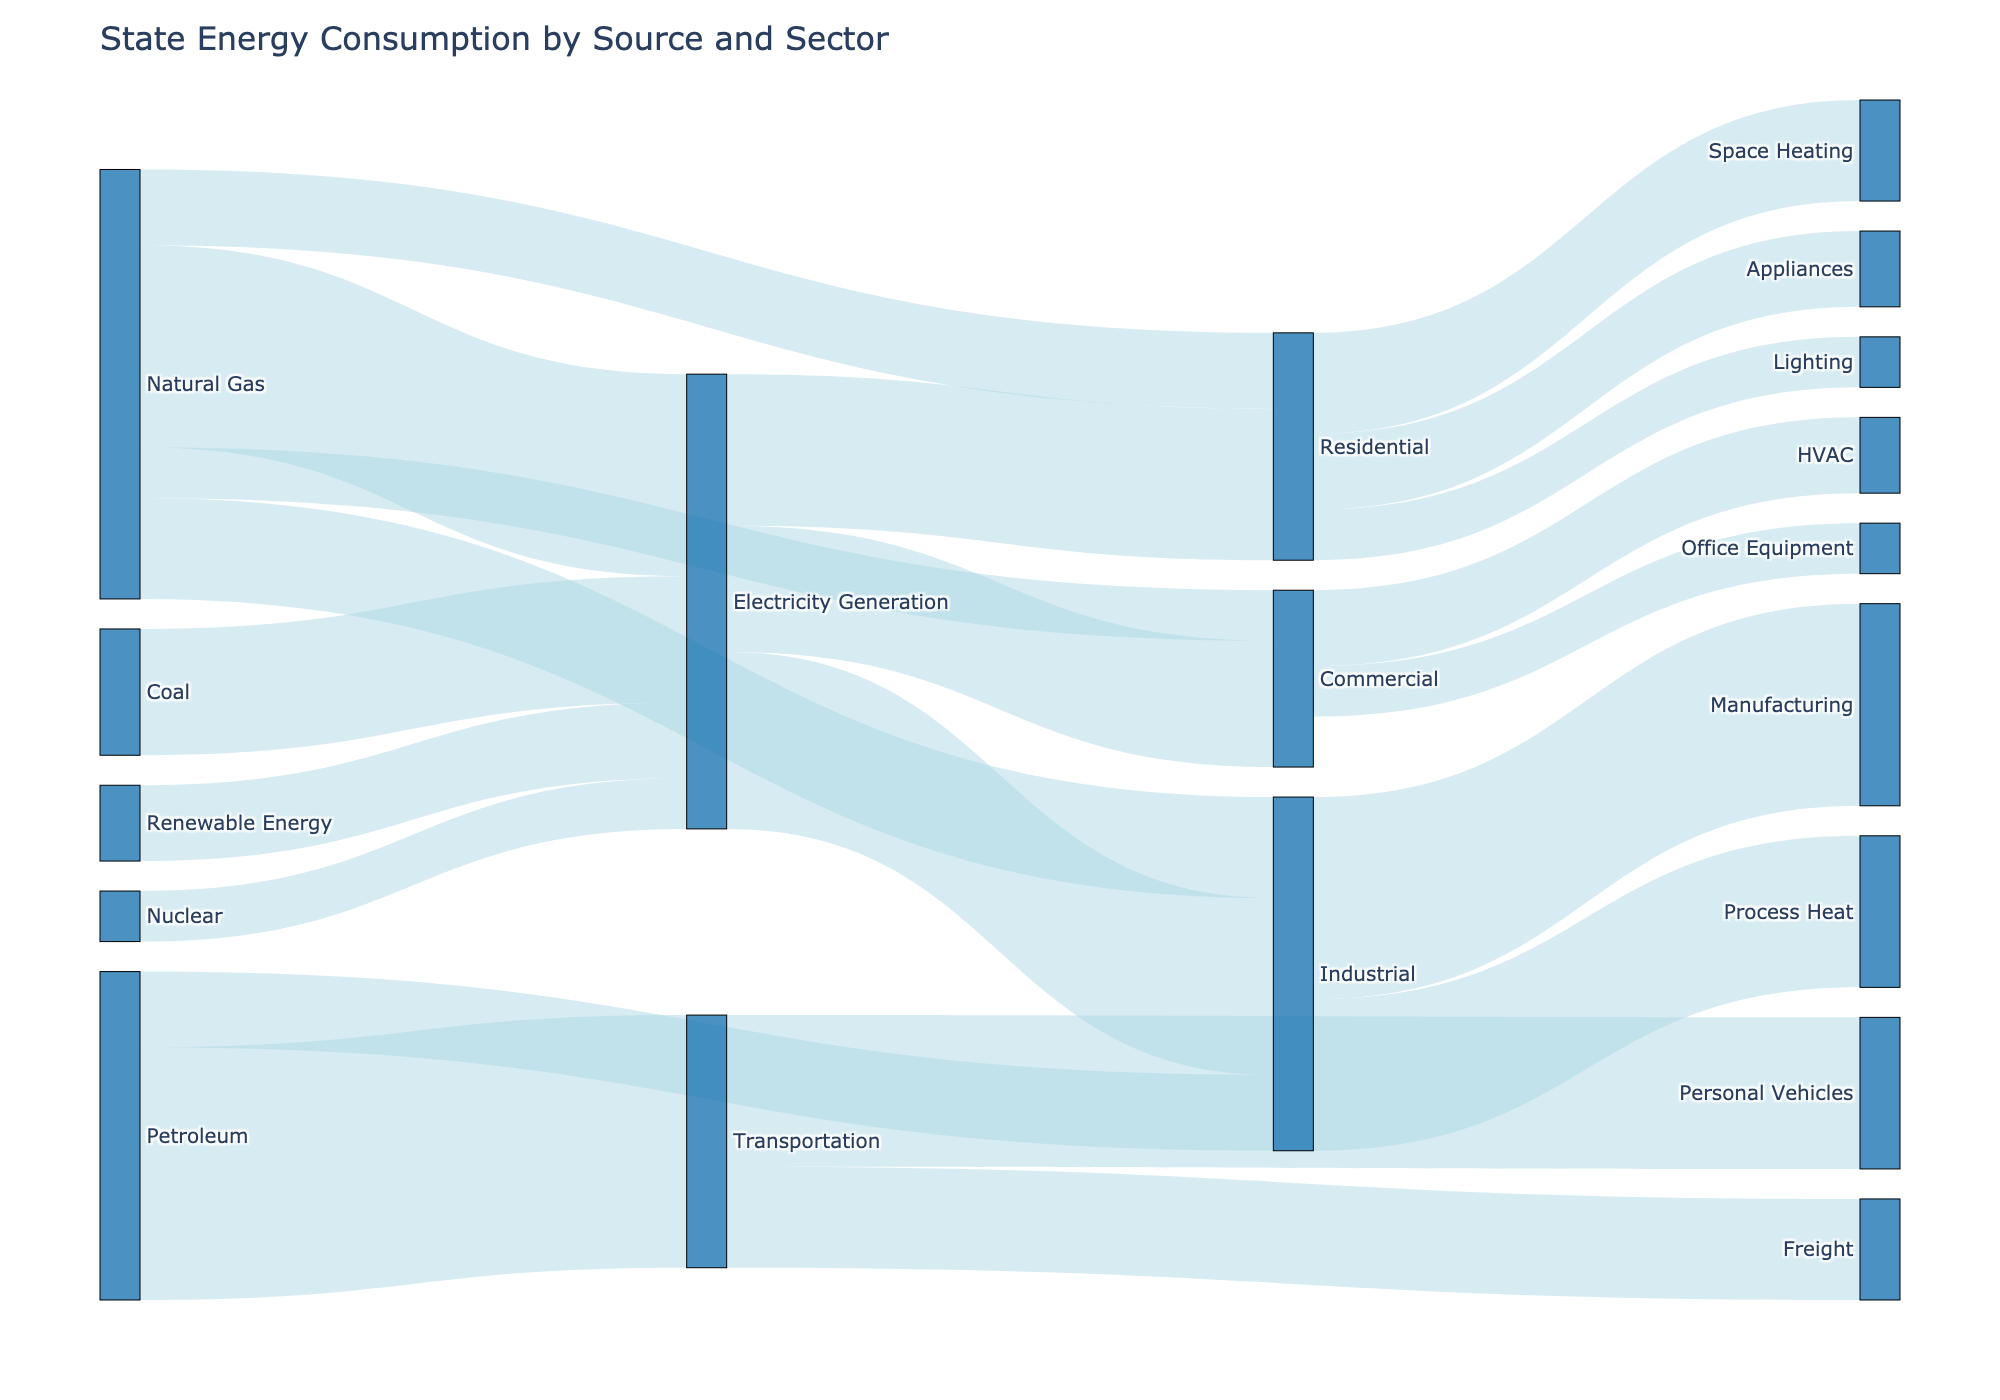What's the primary source of energy for electricity generation? The Sankey diagram shows the flow of energy sources to their usage sectors. The largest flow to 'Electricity Generation' is from 'Natural Gas' with a value of 400, making it the primary source.
Answer: Natural Gas Which sector consumes the most electricity? The 'Electricity Generation' node distributes energy to various sectors. Comparing the value flows, 'Industrial' receives 350, the highest among the sectors.
Answer: Industrial How much energy does the transportation sector consume directly from petroleum? Look at the flow from 'Petroleum' to 'Transportation' in the diagram, which shows a value of 500.
Answer: 500 What is the total energy consumption by the Industrial sector? Sum the values flowing into 'Industrial': 350 from 'Electricity Generation', 200 from 'Natural Gas', and 150 from 'Petroleum' totaling 700.
Answer: 700 Which energy source contributes the least to electricity generation? Compare the values flowing into 'Electricity Generation': 'Renewable Energy' (150), 'Nuclear' (100), 'Coal' (250), and 'Natural Gas' (400). 'Nuclear' contributes the least with 100.
Answer: Nuclear How does the energy consumption for 'Space Heating' in the Residential sector compare to 'Appliances'? In the Residential sector, 'Space Heating' consumes 200, while 'Appliances' consumes 150. 200 is greater than 150.
Answer: Space Heating consumes more Calculate the total amount of energy consumed by the Residential sector. Sum values for Residential inflows: 150 (Natural Gas) and values for Residential outflows: 300 (Electricity Generation). Total: 150 + 300 = 450. Validate the flow consistency for sectors.
Answer: 450 What percentage of total transportation energy consumption is used by personal vehicles? Transportation's total is 500 (direct from Petroleum). Personal Vehicles consume 300. Percentage = (300 / 500) * 100 = 60%.
Answer: 60% Is the commercial sector more dependent on Natural Gas or Electricity? Compare the values: 150 for Electricity and 100 for Natural Gas in the Commercial sector. It is more dependent on Electricity.
Answer: Electricity How much energy is used in Manufacturing within the Industrial sector relative to Process Heat? For the Industrial sector, 'Manufacturing' consumes 400, and 'Process Heat' consumes 300. 'Manufacturing' uses 100 more.
Answer: 100 more 